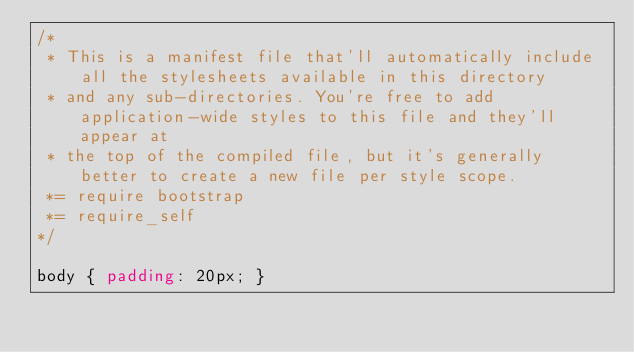Convert code to text. <code><loc_0><loc_0><loc_500><loc_500><_CSS_>/*
 * This is a manifest file that'll automatically include all the stylesheets available in this directory
 * and any sub-directories. You're free to add application-wide styles to this file and they'll appear at
 * the top of the compiled file, but it's generally better to create a new file per style scope.
 *= require bootstrap
 *= require_self
*/

body { padding: 20px; }
</code> 